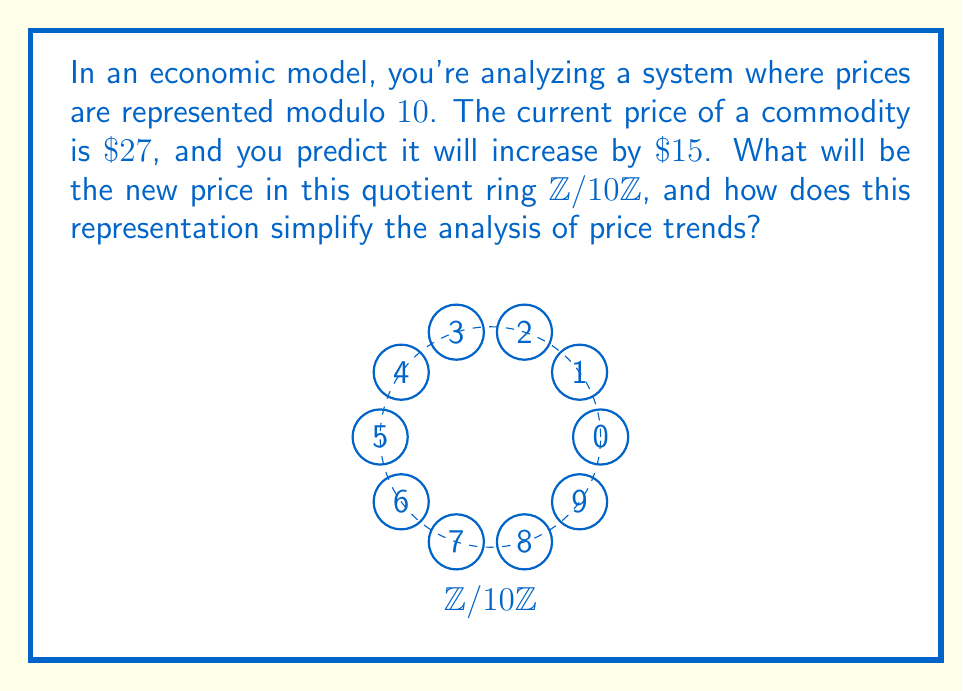Can you solve this math problem? 1) In the quotient ring $\mathbb{Z}/10\mathbb{Z}$, all integers are represented by their remainder when divided by 10. This creates a cyclic structure with 10 elements: $\{0, 1, 2, ..., 9\}$.

2) The current price $27 \equiv 7 \pmod{10}$, as $27 = 2 \cdot 10 + 7$.

3) The predicted increase of $15 \equiv 5 \pmod{10}$, as $15 = 1 \cdot 10 + 5$.

4) To find the new price, we add these values in $\mathbb{Z}/10\mathbb{Z}$:
   $7 + 5 = 12 \equiv 2 \pmod{10}$

5) This representation simplifies the analysis by:
   a) Reducing all prices to a finite set of values (0-9).
   b) Automatically accounting for cyclic patterns in price movements.
   c) Allowing for easy identification of price thresholds or breakpoints.
   d) Simplifying calculations by working with smaller numbers.

6) In economic terms, this could represent a simplified way to track inflation cycles, price elasticity thresholds, or consumer psychology breakpoints in pricing strategies.
Answer: $2$ in $\mathbb{Z}/10\mathbb{Z}$ 